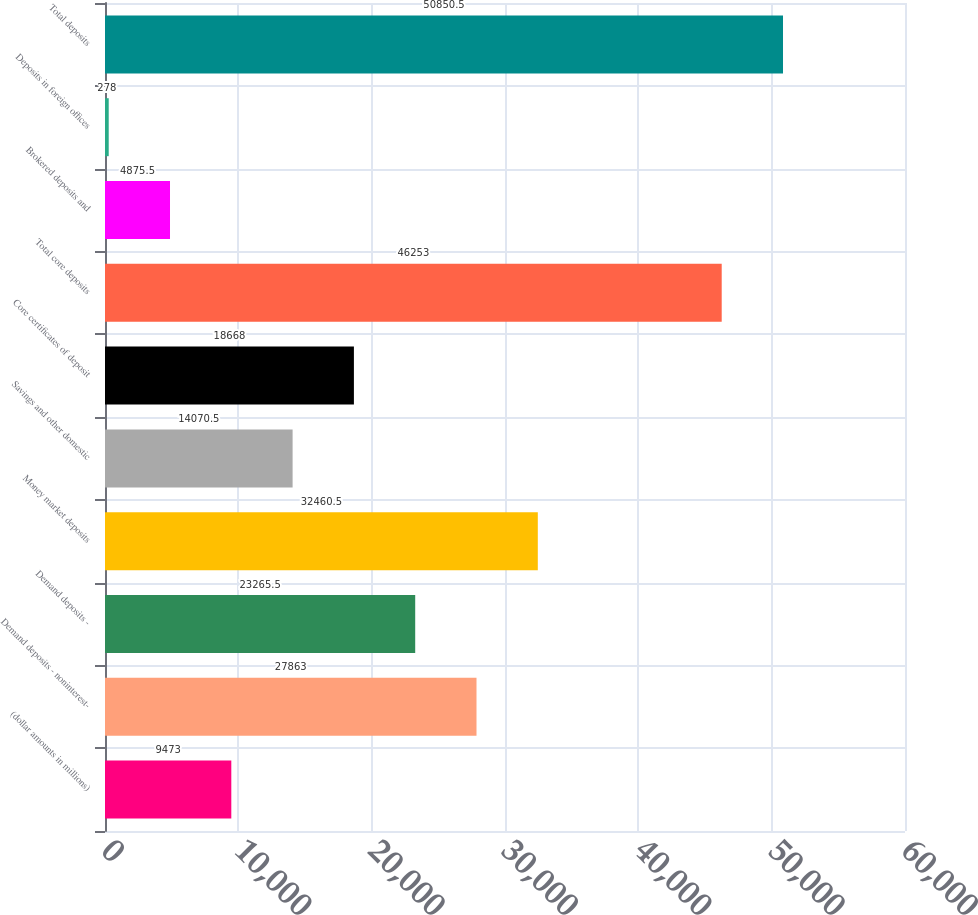Convert chart. <chart><loc_0><loc_0><loc_500><loc_500><bar_chart><fcel>(dollar amounts in millions)<fcel>Demand deposits - noninterest-<fcel>Demand deposits -<fcel>Money market deposits<fcel>Savings and other domestic<fcel>Core certificates of deposit<fcel>Total core deposits<fcel>Brokered deposits and<fcel>Deposits in foreign offices<fcel>Total deposits<nl><fcel>9473<fcel>27863<fcel>23265.5<fcel>32460.5<fcel>14070.5<fcel>18668<fcel>46253<fcel>4875.5<fcel>278<fcel>50850.5<nl></chart> 